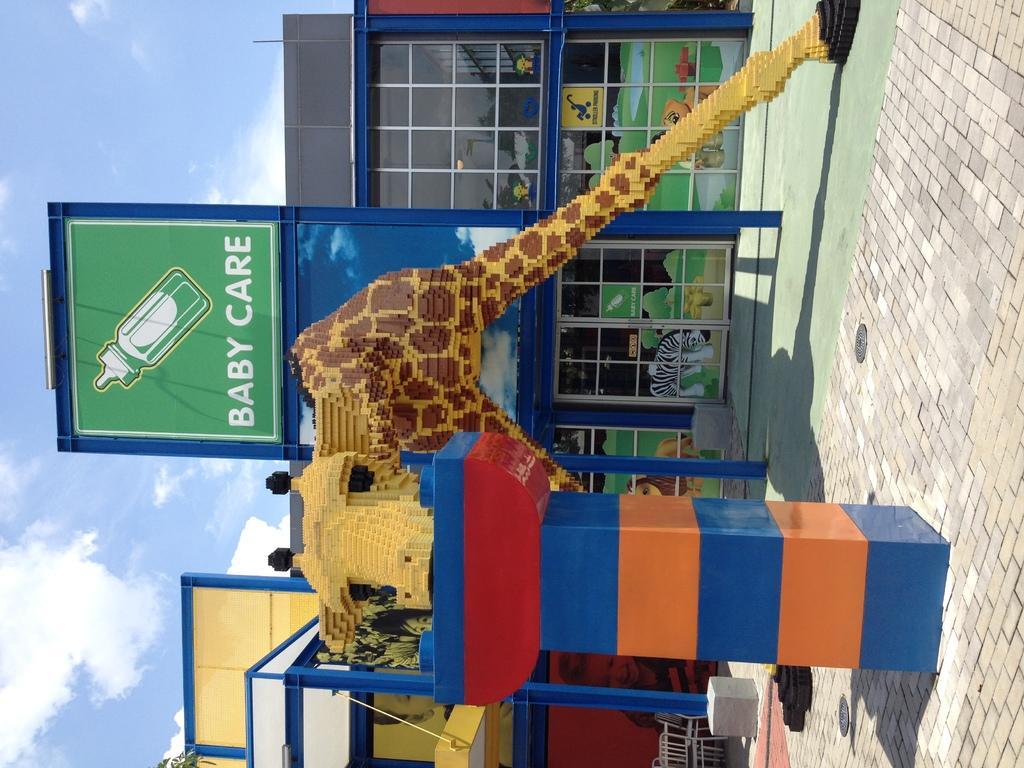In one or two sentences, can you explain what this image depicts? In the picture we can see a sculpture of a giraffe on the surface and behind it, we can see a shop with a name baby care on it and in the background we can see the sky with clouds. 